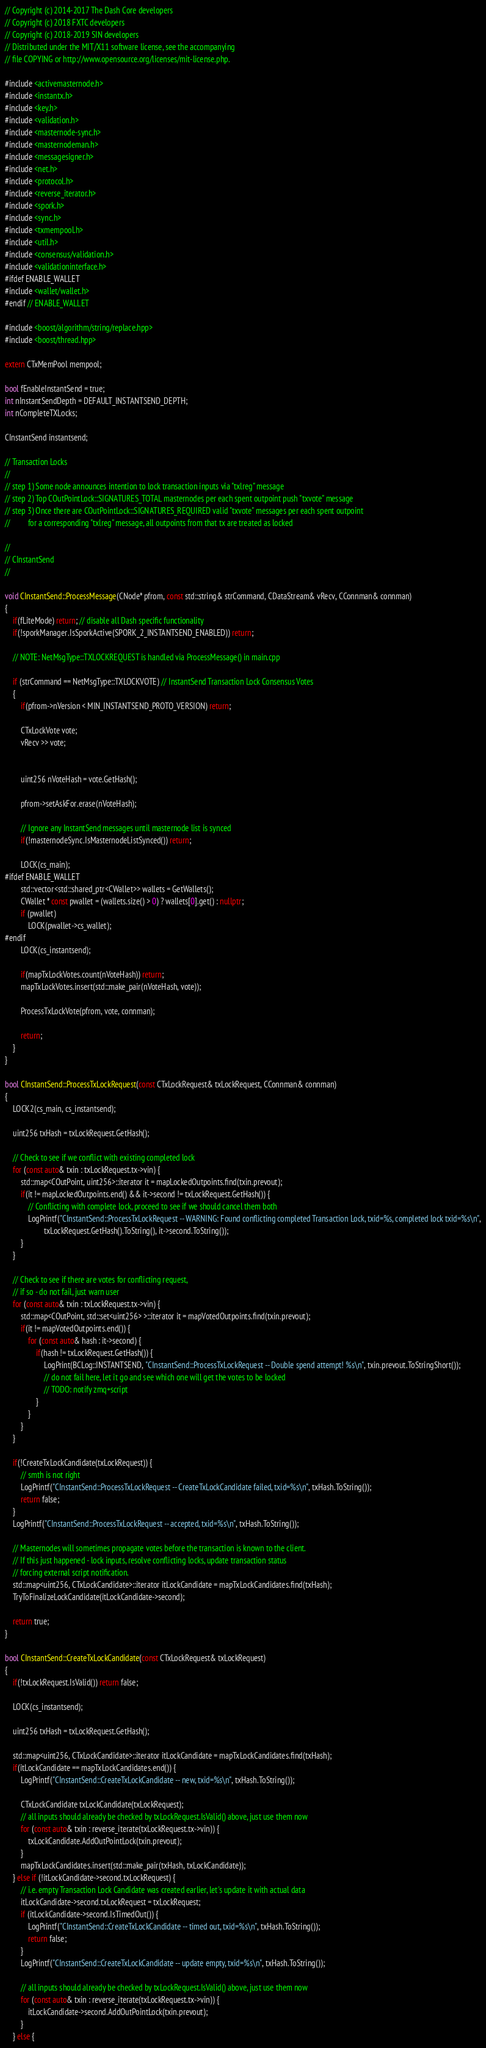Convert code to text. <code><loc_0><loc_0><loc_500><loc_500><_C++_>// Copyright (c) 2014-2017 The Dash Core developers
// Copyright (c) 2018 FXTC developers
// Copyright (c) 2018-2019 SIN developers
// Distributed under the MIT/X11 software license, see the accompanying
// file COPYING or http://www.opensource.org/licenses/mit-license.php.

#include <activemasternode.h>
#include <instantx.h>
#include <key.h>
#include <validation.h>
#include <masternode-sync.h>
#include <masternodeman.h>
#include <messagesigner.h>
#include <net.h>
#include <protocol.h>
#include <reverse_iterator.h>
#include <spork.h>
#include <sync.h>
#include <txmempool.h>
#include <util.h>
#include <consensus/validation.h>
#include <validationinterface.h>
#ifdef ENABLE_WALLET
#include <wallet/wallet.h>
#endif // ENABLE_WALLET

#include <boost/algorithm/string/replace.hpp>
#include <boost/thread.hpp>

extern CTxMemPool mempool;

bool fEnableInstantSend = true;
int nInstantSendDepth = DEFAULT_INSTANTSEND_DEPTH;
int nCompleteTXLocks;

CInstantSend instantsend;

// Transaction Locks
//
// step 1) Some node announces intention to lock transaction inputs via "txlreg" message
// step 2) Top COutPointLock::SIGNATURES_TOTAL masternodes per each spent outpoint push "txvote" message
// step 3) Once there are COutPointLock::SIGNATURES_REQUIRED valid "txvote" messages per each spent outpoint
//         for a corresponding "txlreg" message, all outpoints from that tx are treated as locked

//
// CInstantSend
//

void CInstantSend::ProcessMessage(CNode* pfrom, const std::string& strCommand, CDataStream& vRecv, CConnman& connman)
{
    if(fLiteMode) return; // disable all Dash specific functionality
    if(!sporkManager.IsSporkActive(SPORK_2_INSTANTSEND_ENABLED)) return;

    // NOTE: NetMsgType::TXLOCKREQUEST is handled via ProcessMessage() in main.cpp

    if (strCommand == NetMsgType::TXLOCKVOTE) // InstantSend Transaction Lock Consensus Votes
    {
        if(pfrom->nVersion < MIN_INSTANTSEND_PROTO_VERSION) return;

        CTxLockVote vote;
        vRecv >> vote;


        uint256 nVoteHash = vote.GetHash();

        pfrom->setAskFor.erase(nVoteHash);

        // Ignore any InstantSend messages until masternode list is synced
        if(!masternodeSync.IsMasternodeListSynced()) return;

        LOCK(cs_main);
#ifdef ENABLE_WALLET
        std::vector<std::shared_ptr<CWallet>> wallets = GetWallets();
        CWallet * const pwallet = (wallets.size() > 0) ? wallets[0].get() : nullptr;
        if (pwallet)
            LOCK(pwallet->cs_wallet);
#endif
        LOCK(cs_instantsend);

        if(mapTxLockVotes.count(nVoteHash)) return;
        mapTxLockVotes.insert(std::make_pair(nVoteHash, vote));

        ProcessTxLockVote(pfrom, vote, connman);

        return;
    }
}

bool CInstantSend::ProcessTxLockRequest(const CTxLockRequest& txLockRequest, CConnman& connman)
{
    LOCK2(cs_main, cs_instantsend);

    uint256 txHash = txLockRequest.GetHash();

    // Check to see if we conflict with existing completed lock
    for (const auto& txin : txLockRequest.tx->vin) {
        std::map<COutPoint, uint256>::iterator it = mapLockedOutpoints.find(txin.prevout);
        if(it != mapLockedOutpoints.end() && it->second != txLockRequest.GetHash()) {
            // Conflicting with complete lock, proceed to see if we should cancel them both
            LogPrintf("CInstantSend::ProcessTxLockRequest -- WARNING: Found conflicting completed Transaction Lock, txid=%s, completed lock txid=%s\n",
                    txLockRequest.GetHash().ToString(), it->second.ToString());
        }
    }

    // Check to see if there are votes for conflicting request,
    // if so - do not fail, just warn user
    for (const auto& txin : txLockRequest.tx->vin) {
        std::map<COutPoint, std::set<uint256> >::iterator it = mapVotedOutpoints.find(txin.prevout);
        if(it != mapVotedOutpoints.end()) {
            for (const auto& hash : it->second) {
                if(hash != txLockRequest.GetHash()) {
                    LogPrint(BCLog::INSTANTSEND, "CInstantSend::ProcessTxLockRequest -- Double spend attempt! %s\n", txin.prevout.ToStringShort());
                    // do not fail here, let it go and see which one will get the votes to be locked
                    // TODO: notify zmq+script
                }
            }
        }
    }

    if(!CreateTxLockCandidate(txLockRequest)) {
        // smth is not right
        LogPrintf("CInstantSend::ProcessTxLockRequest -- CreateTxLockCandidate failed, txid=%s\n", txHash.ToString());
        return false;
    }
    LogPrintf("CInstantSend::ProcessTxLockRequest -- accepted, txid=%s\n", txHash.ToString());

    // Masternodes will sometimes propagate votes before the transaction is known to the client.
    // If this just happened - lock inputs, resolve conflicting locks, update transaction status
    // forcing external script notification.
    std::map<uint256, CTxLockCandidate>::iterator itLockCandidate = mapTxLockCandidates.find(txHash);
    TryToFinalizeLockCandidate(itLockCandidate->second);

    return true;
}

bool CInstantSend::CreateTxLockCandidate(const CTxLockRequest& txLockRequest)
{
    if(!txLockRequest.IsValid()) return false;

    LOCK(cs_instantsend);

    uint256 txHash = txLockRequest.GetHash();

    std::map<uint256, CTxLockCandidate>::iterator itLockCandidate = mapTxLockCandidates.find(txHash);
    if(itLockCandidate == mapTxLockCandidates.end()) {
        LogPrintf("CInstantSend::CreateTxLockCandidate -- new, txid=%s\n", txHash.ToString());

        CTxLockCandidate txLockCandidate(txLockRequest);
        // all inputs should already be checked by txLockRequest.IsValid() above, just use them now
        for (const auto& txin : reverse_iterate(txLockRequest.tx->vin)) {
            txLockCandidate.AddOutPointLock(txin.prevout);
        }
        mapTxLockCandidates.insert(std::make_pair(txHash, txLockCandidate));
    } else if (!itLockCandidate->second.txLockRequest) {
        // i.e. empty Transaction Lock Candidate was created earlier, let's update it with actual data
        itLockCandidate->second.txLockRequest = txLockRequest;
        if (itLockCandidate->second.IsTimedOut()) {
            LogPrintf("CInstantSend::CreateTxLockCandidate -- timed out, txid=%s\n", txHash.ToString());
            return false;
        }
        LogPrintf("CInstantSend::CreateTxLockCandidate -- update empty, txid=%s\n", txHash.ToString());

        // all inputs should already be checked by txLockRequest.IsValid() above, just use them now
        for (const auto& txin : reverse_iterate(txLockRequest.tx->vin)) {
            itLockCandidate->second.AddOutPointLock(txin.prevout);
        }
    } else {</code> 